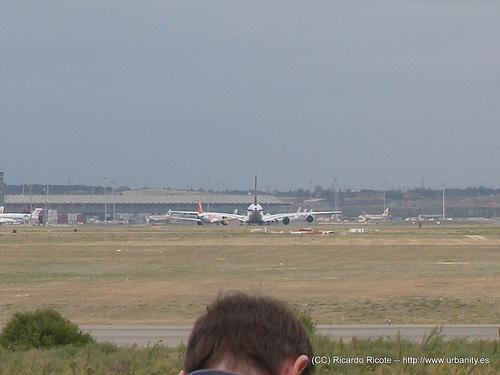Briefly describe the scene of the airport. There is a white plane on the runway with a red tail, surrounded by green and brown fields, grey roads, and distant trees. Describe the main features of the airport. The airport has a white plane on the runway, a red tail on the plane, a group of planes in the distance, green grass on the ground, and a view of the airport. What is the predominant weather according to the image? The predominant weather is overcast due to the presence of grey and cloudy sky, thick clouds covering the sky, and white clouds in the blue sky. Mention five elements or objects that are present in the sky. White clouds, blue sky, grey and cloudy sky, thick clouds cover the sky, and overcast sky. List three elements present in the vicinity of the planes. Green and brown field, grey road near the field, and trees in the far distance. Which task would be best suited for identifying and locating clouds in the sky? Referential expression grounding task. What type of task would be most appropriate for differentiating between the various sky elements in the image? Multi-choice VQA task. 